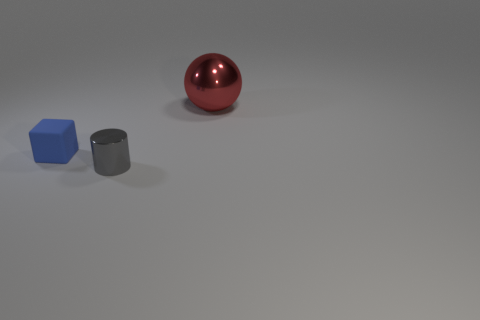Add 3 tiny cyan metal blocks. How many objects exist? 6 Subtract all cylinders. How many objects are left? 2 Subtract 0 yellow cylinders. How many objects are left? 3 Subtract all brown rubber cubes. Subtract all big red things. How many objects are left? 2 Add 2 tiny blue cubes. How many tiny blue cubes are left? 3 Add 3 gray shiny cylinders. How many gray shiny cylinders exist? 4 